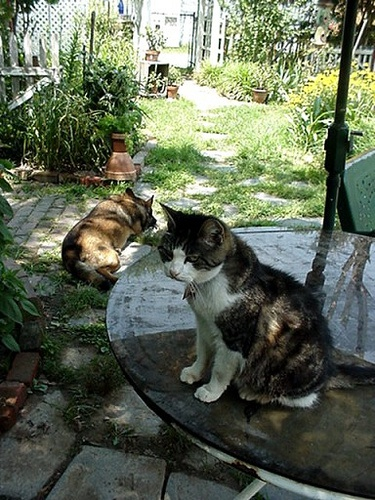Describe the objects in this image and their specific colors. I can see dining table in darkgreen, black, gray, and darkgray tones, cat in darkgreen, black, gray, and darkgray tones, potted plant in darkgreen and black tones, dog in darkgreen, black, gray, and tan tones, and chair in darkgreen, teal, and black tones in this image. 